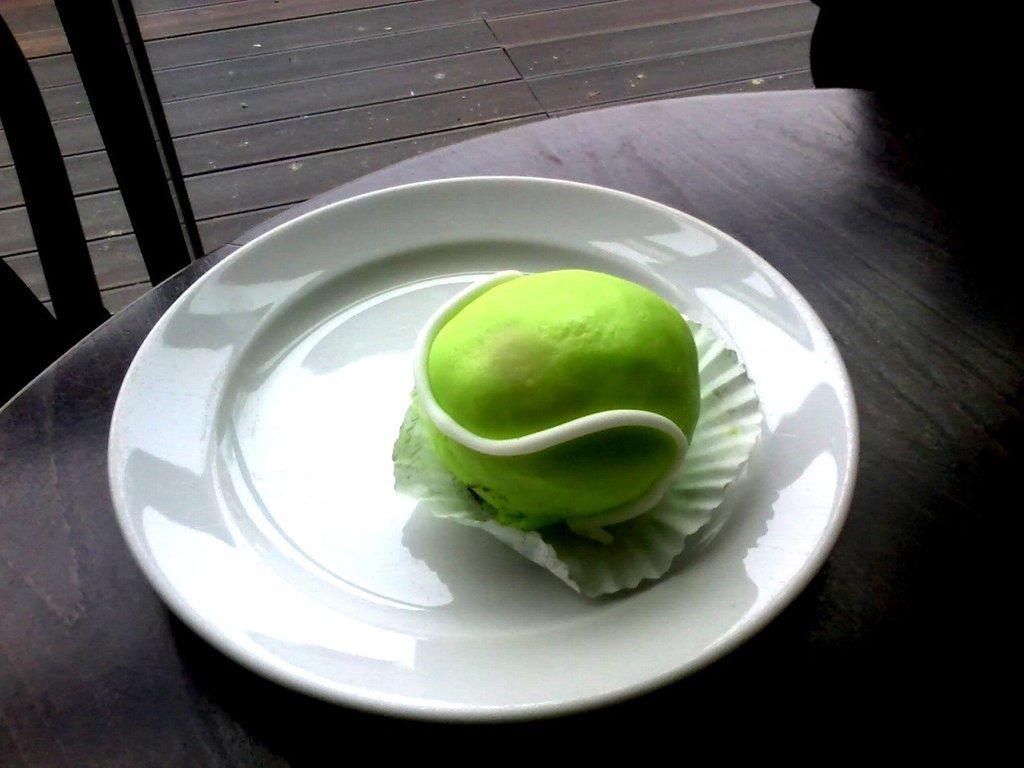Describe this image in one or two sentences. In the foreground of this image, there is a food item on a platter which is on a table. At the top, it seems like chairs and the floor. 